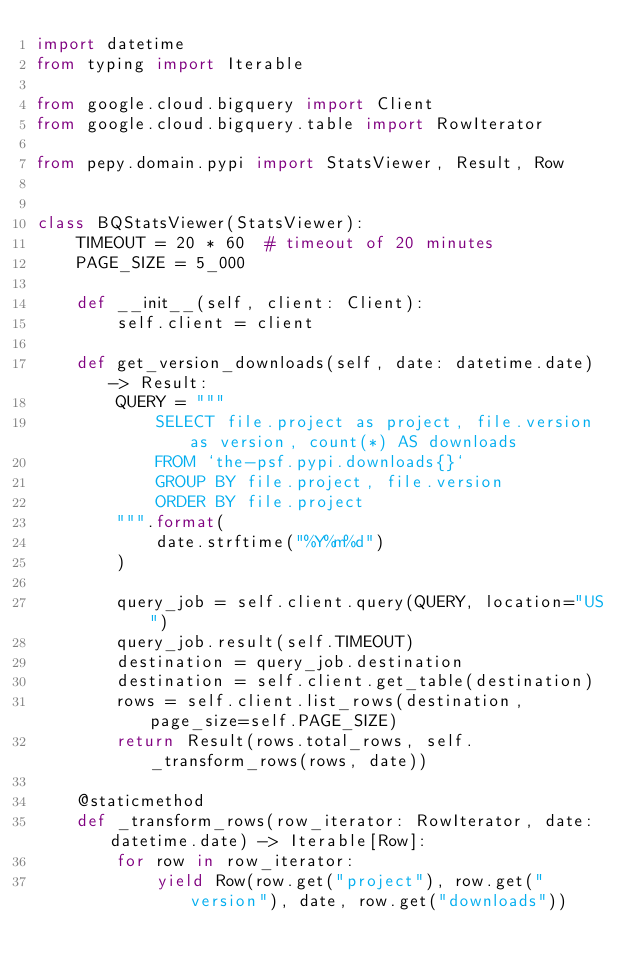<code> <loc_0><loc_0><loc_500><loc_500><_Python_>import datetime
from typing import Iterable

from google.cloud.bigquery import Client
from google.cloud.bigquery.table import RowIterator

from pepy.domain.pypi import StatsViewer, Result, Row


class BQStatsViewer(StatsViewer):
    TIMEOUT = 20 * 60  # timeout of 20 minutes
    PAGE_SIZE = 5_000

    def __init__(self, client: Client):
        self.client = client

    def get_version_downloads(self, date: datetime.date) -> Result:
        QUERY = """
            SELECT file.project as project, file.version as version, count(*) AS downloads
            FROM `the-psf.pypi.downloads{}`
            GROUP BY file.project, file.version
            ORDER BY file.project
        """.format(
            date.strftime("%Y%m%d")
        )

        query_job = self.client.query(QUERY, location="US")
        query_job.result(self.TIMEOUT)
        destination = query_job.destination
        destination = self.client.get_table(destination)
        rows = self.client.list_rows(destination, page_size=self.PAGE_SIZE)
        return Result(rows.total_rows, self._transform_rows(rows, date))

    @staticmethod
    def _transform_rows(row_iterator: RowIterator, date: datetime.date) -> Iterable[Row]:
        for row in row_iterator:
            yield Row(row.get("project"), row.get("version"), date, row.get("downloads"))
</code> 